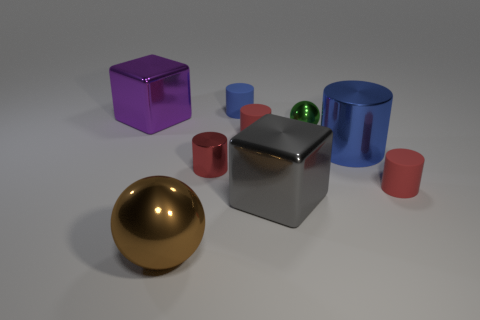Subtract all tiny red metal cylinders. How many cylinders are left? 4 Subtract all red cylinders. How many cylinders are left? 2 Subtract 2 balls. How many balls are left? 0 Subtract all cylinders. How many objects are left? 4 Subtract all green cylinders. Subtract all brown spheres. How many cylinders are left? 5 Subtract all yellow balls. How many blue cylinders are left? 2 Subtract all yellow shiny cylinders. Subtract all brown metallic spheres. How many objects are left? 8 Add 8 brown metallic balls. How many brown metallic balls are left? 9 Add 7 large gray metal things. How many large gray metal things exist? 8 Subtract 1 blue cylinders. How many objects are left? 8 